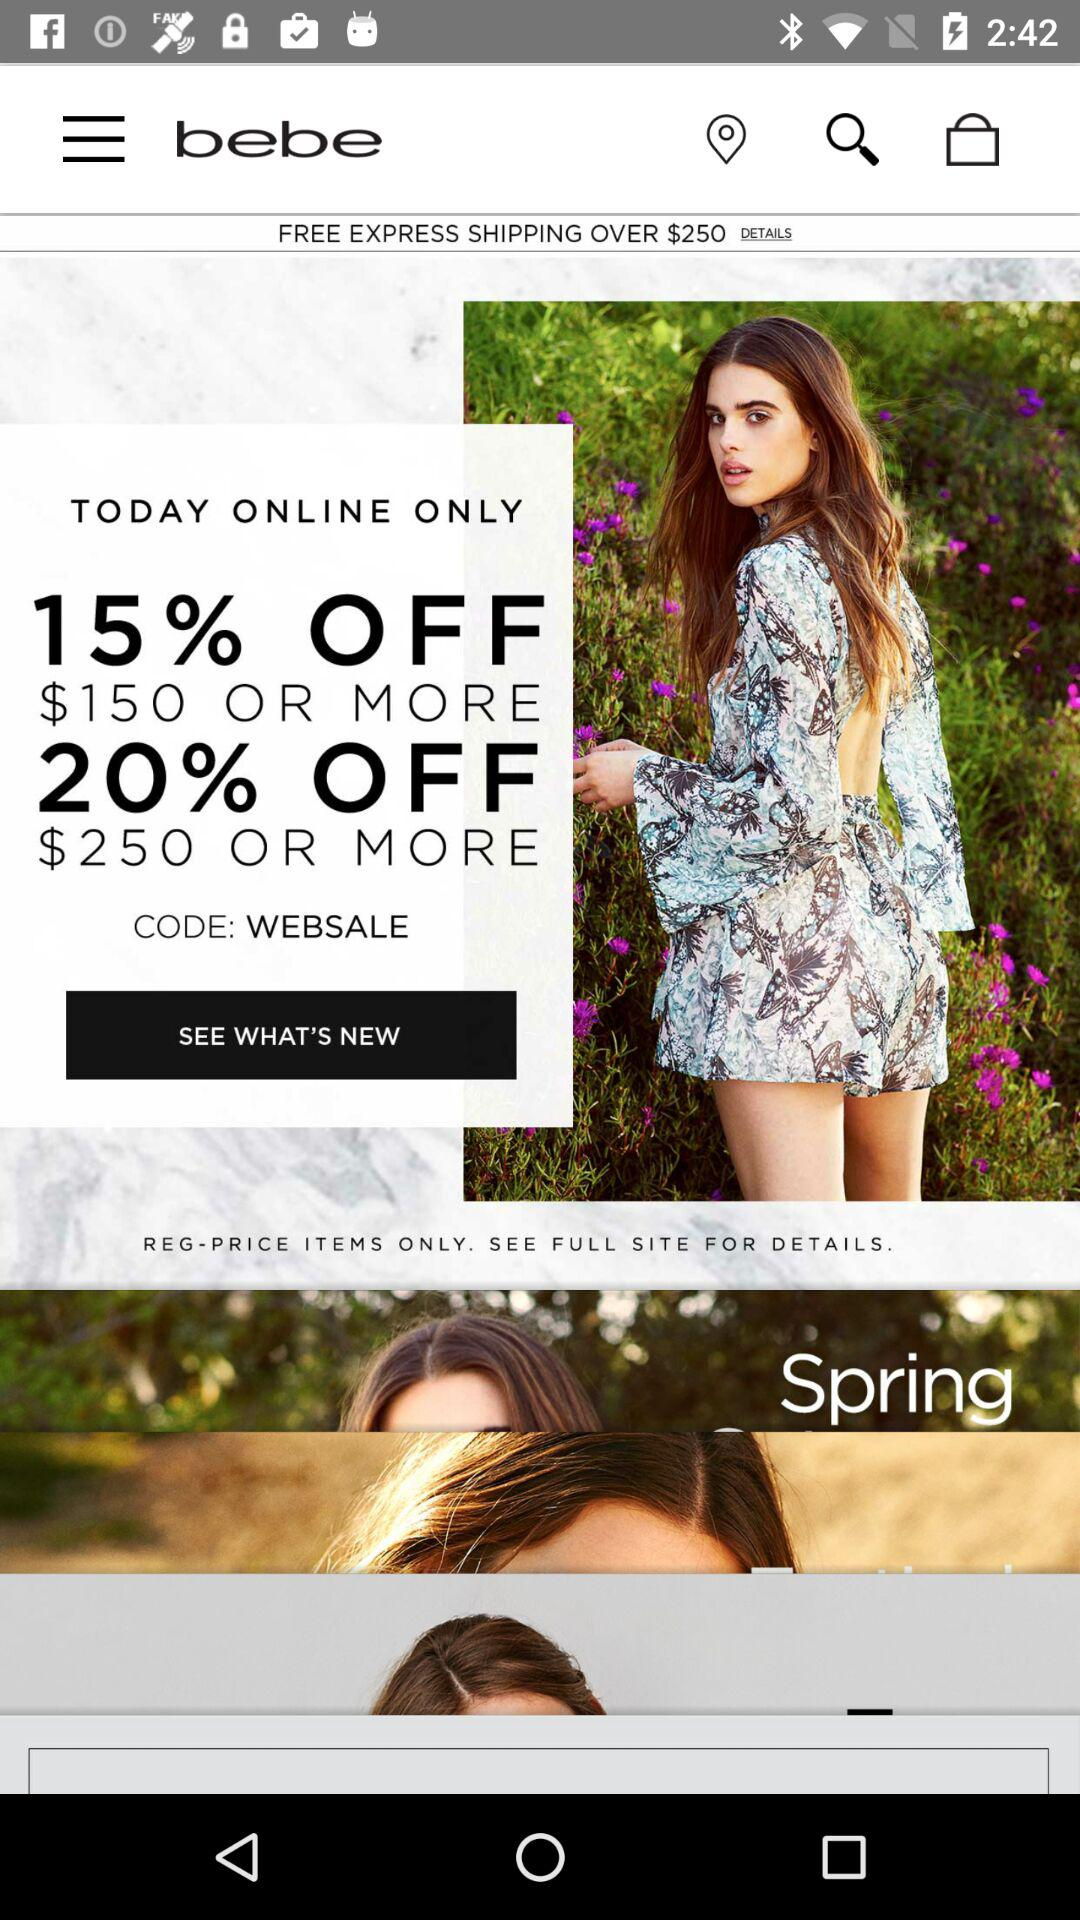Is express shipping over $250 free or paid? Express shipping over $250 is free. 